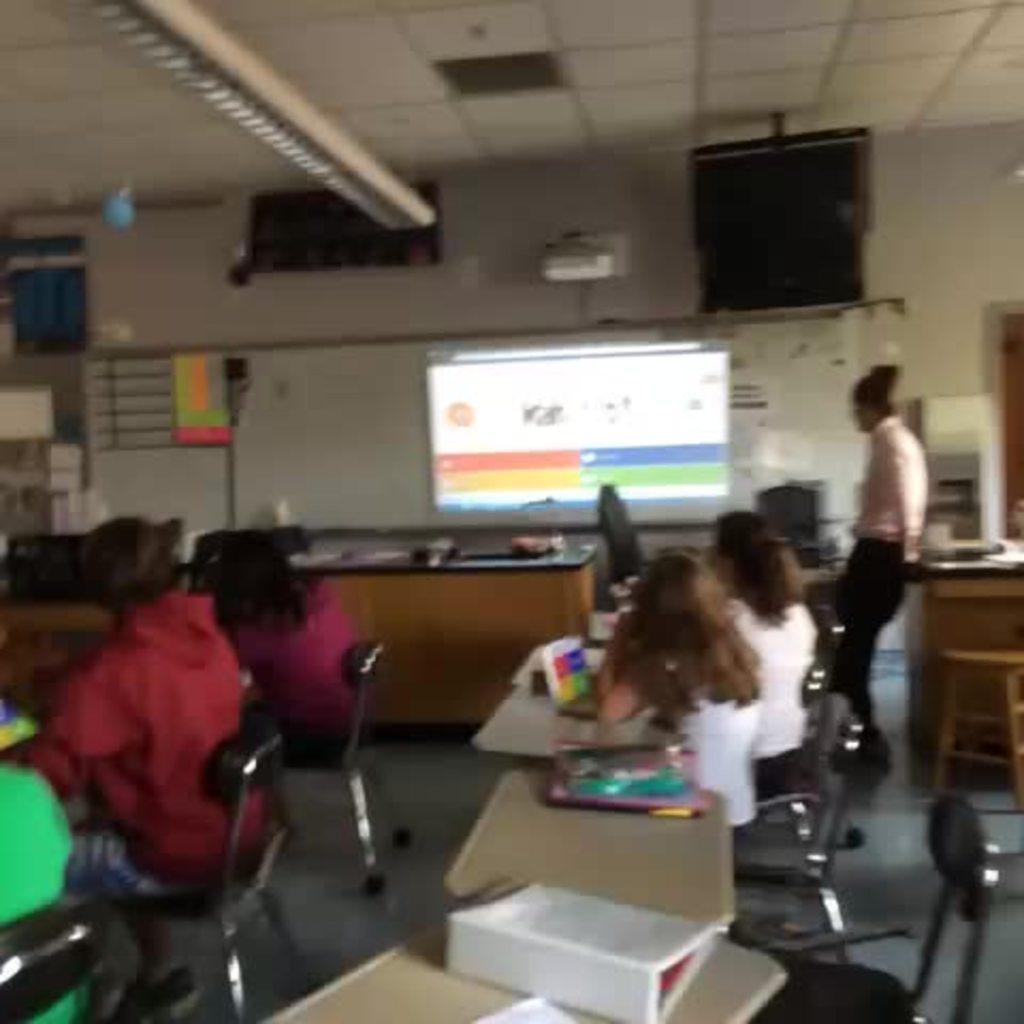In one or two sentences, can you explain what this image depicts? In this image I can see people sitting. There are tables on which there are few objects. A person is standing on the right. There is a projector at the back. This is a blurred image. 